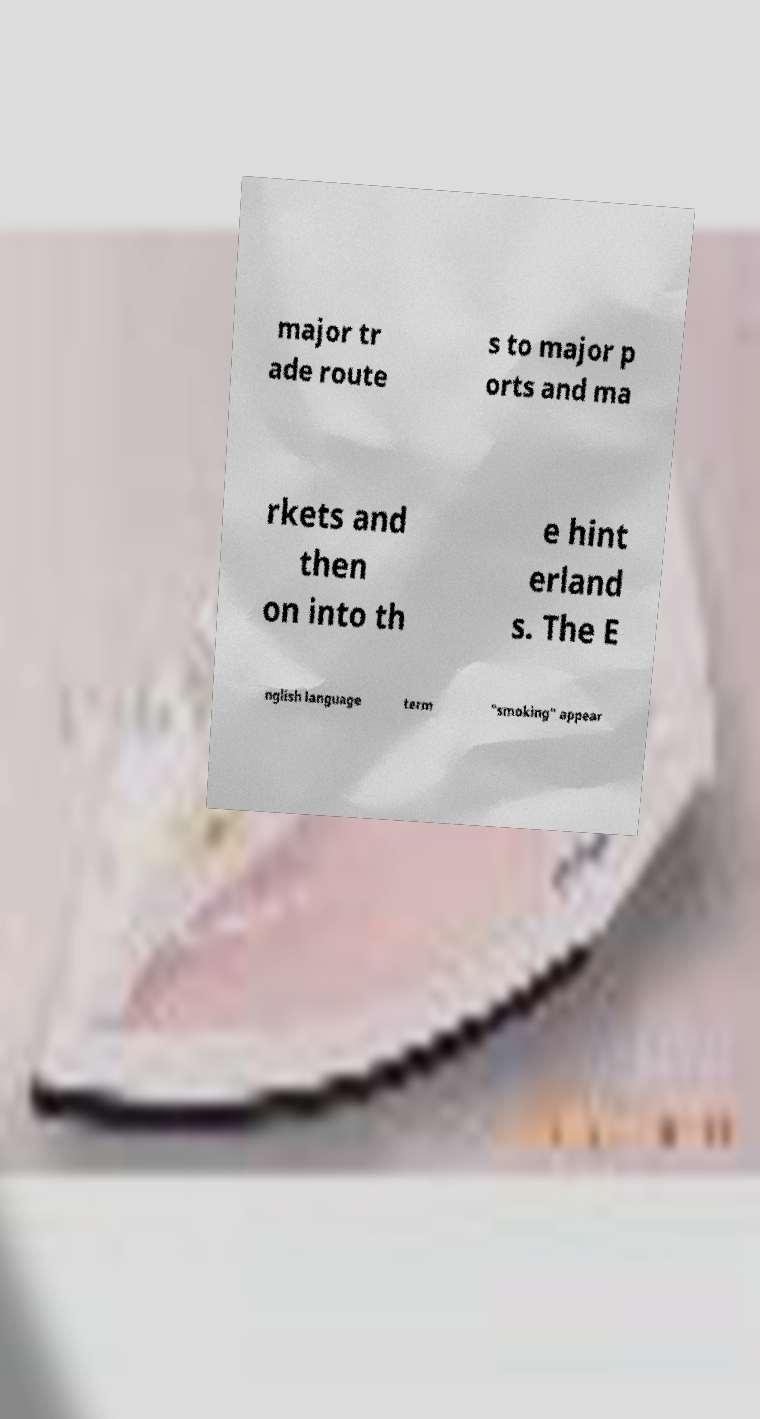Can you read and provide the text displayed in the image?This photo seems to have some interesting text. Can you extract and type it out for me? major tr ade route s to major p orts and ma rkets and then on into th e hint erland s. The E nglish language term "smoking" appear 